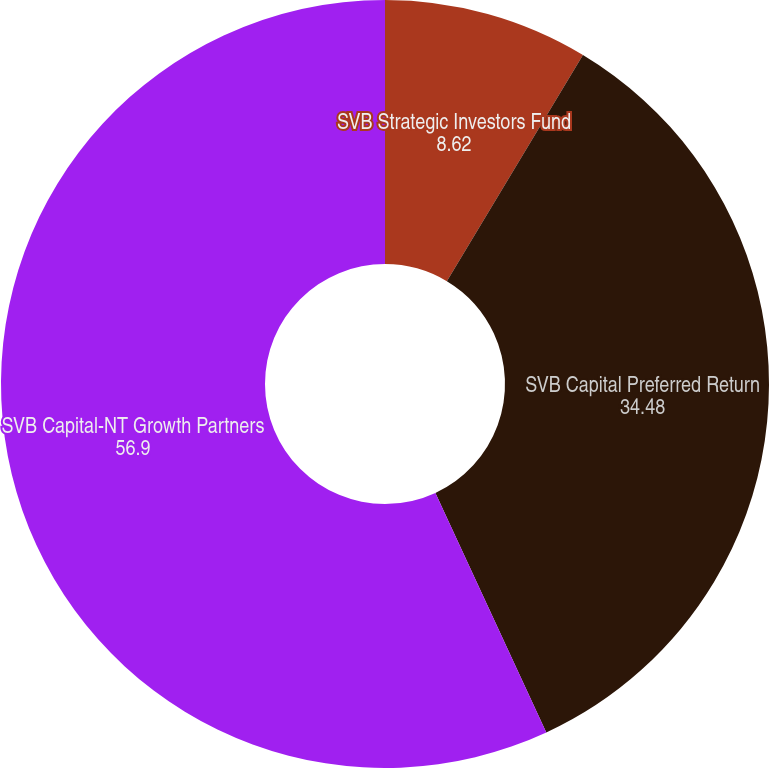<chart> <loc_0><loc_0><loc_500><loc_500><pie_chart><fcel>SVB Strategic Investors Fund<fcel>SVB Capital Preferred Return<fcel>SVB Capital-NT Growth Partners<nl><fcel>8.62%<fcel>34.48%<fcel>56.9%<nl></chart> 